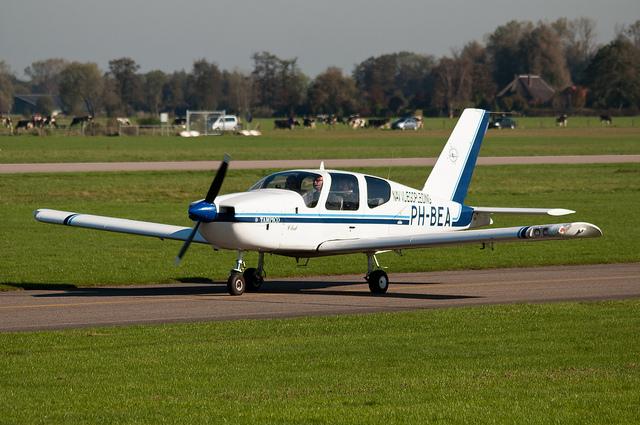What letters are on the side of the plane?
Be succinct. Ph-bea. What color is the plane?
Short answer required. White. Is this a propeller plane?
Concise answer only. Yes. 